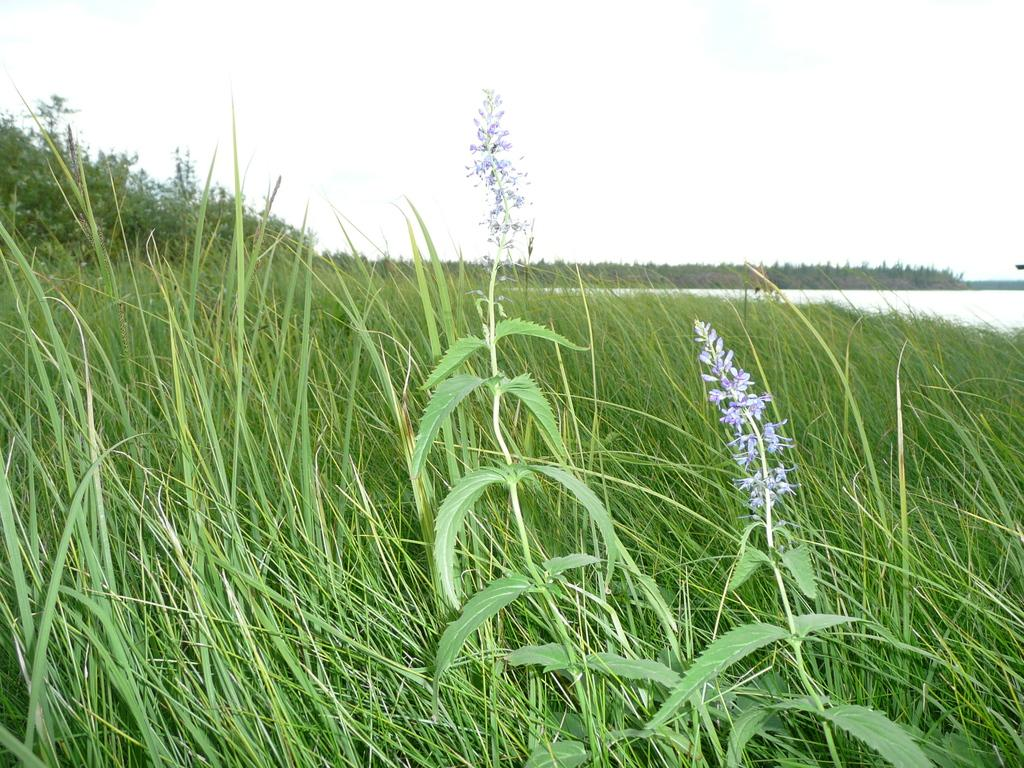What type of plant is present in the image? There are flowers on a plant in the image. What type of vegetation can be seen in the image besides the plant? There is grass visible in the image. What else is visible in the image besides the plant and grass? There is water visible in the image. What type of berry is growing on the cabbage in the image? There is no cabbage or berry present in the image. 